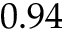<formula> <loc_0><loc_0><loc_500><loc_500>0 . 9 4</formula> 